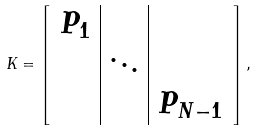Convert formula to latex. <formula><loc_0><loc_0><loc_500><loc_500>K = \left [ \begin{array} { c | c | c } P _ { 1 } & & \\ & \ddots & \\ & & P _ { N - 1 } \end{array} \right ] ,</formula> 